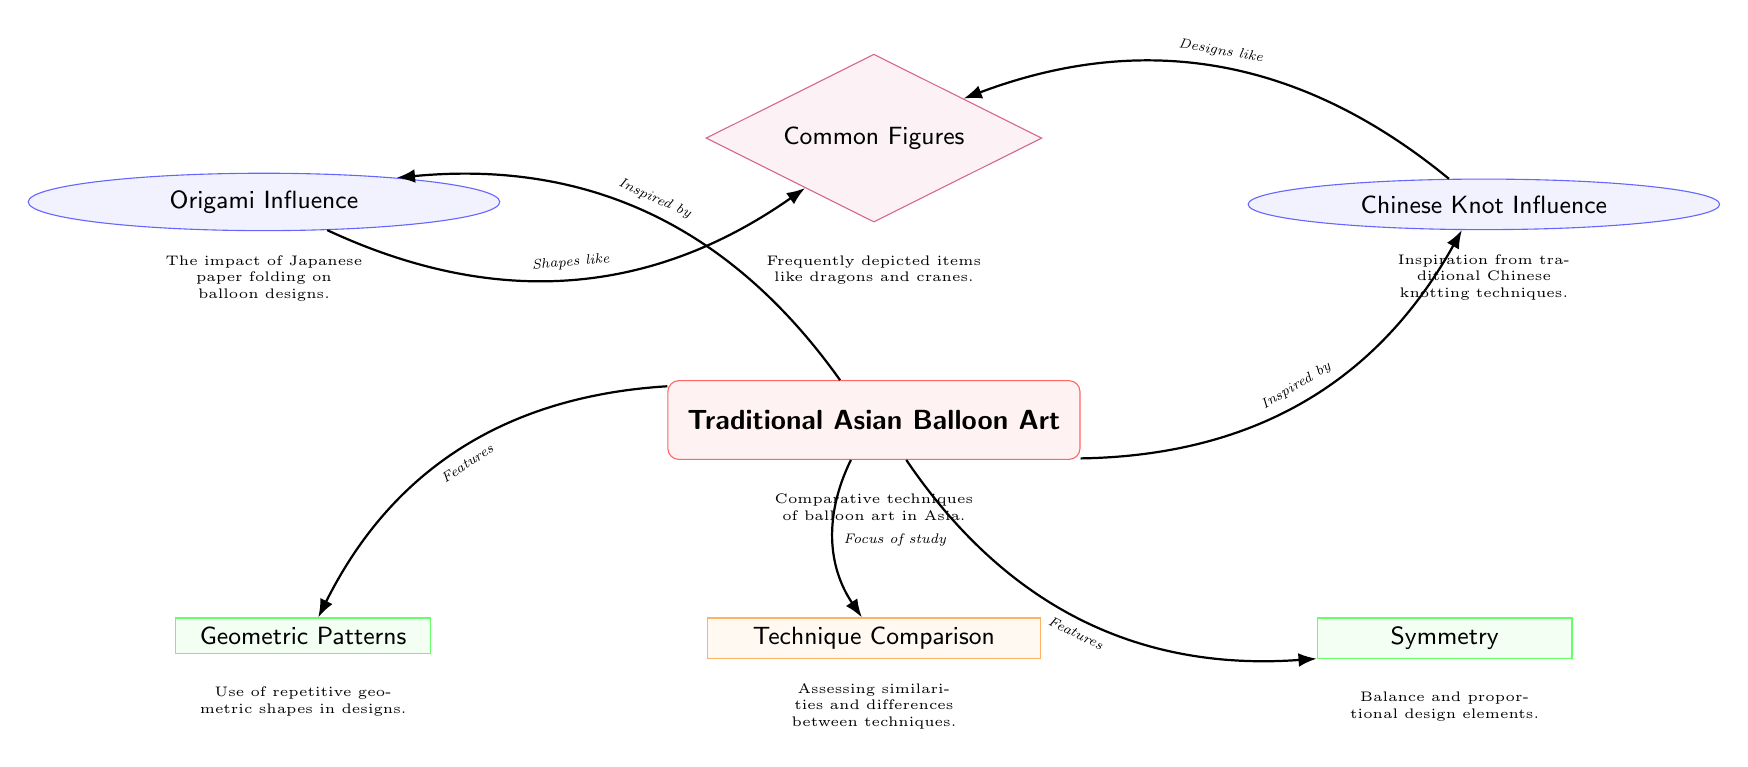What is the main topic of the diagram? The title of the diagram is "Traditional Asian Balloon Art," which clearly indicates that this is the primary focus of the visual representation.
Answer: Traditional Asian Balloon Art How many themes influence the main topic? The main topic is influenced by two themes: "Origami Influence" and "Chinese Knot Influence," as shown by the edges connecting them to the main topic.
Answer: 2 What feature involves repetitive geometric shapes? The diagram explicitly lists "Geometric Patterns" as a feature of traditional Asian balloon art, shown below the main topic with an edge connecting them.
Answer: Geometric Patterns What is the relationship between "Origami Influence" and "Common Figures"? The edge drawn from "Origami Influence" to "Common Figures" indicates that origami shapes have inspired the figures commonly depicted in balloon art.
Answer: Shapes like What does the analysis node focus on? The "Technique Comparison" node, which is below the main topic, indicates that the diagram focuses on comparing different techniques used in traditional Asian balloon art.
Answer: Technique Comparison Which design is inspired by traditional Chinese techniques? "Designs like" indicates that the figures have design inspirations specifically from Chinese knotting techniques, as shown by the edge from the "Chinese Knot Influence" node.
Answer: Designs like How does the diagram categorize the elements of traditional Asian balloon art? The elements are categorized into themes and features as observed in the structure; themes show influences, while features present characteristics.
Answer: Themes and features Name a common figure depicted in traditional Asian balloon art. The diagram mentions "Common Figures" but does not specify individual figures; however, "dragons" and "cranes" are typical examples.
Answer: Common Figures What color represents "Technique Comparison"? The node representing "Technique Comparison" is filled with orange, indicating that it is specifically categorized with this color in the diagram.
Answer: Orange 